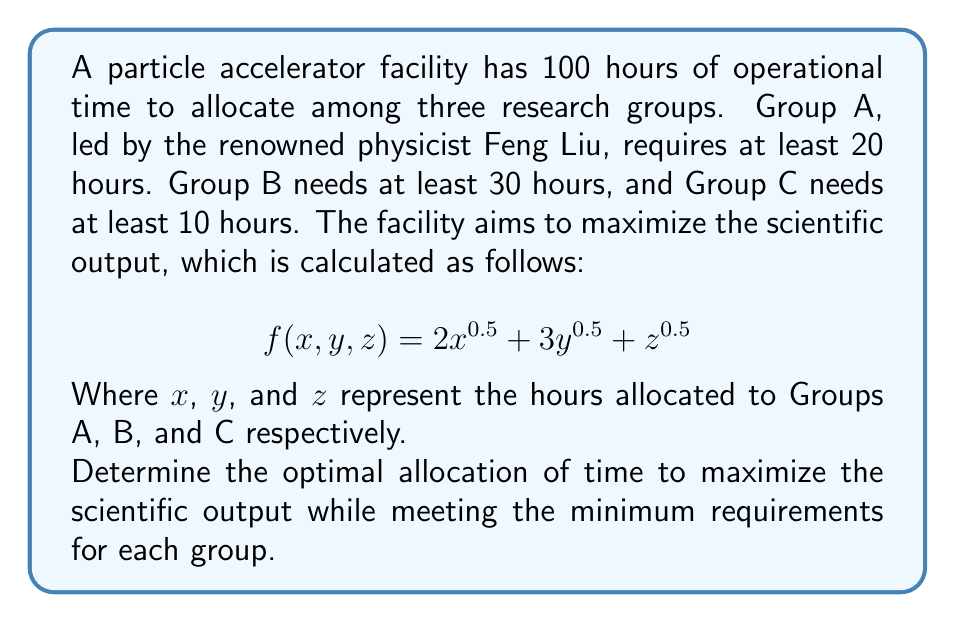Provide a solution to this math problem. To solve this problem, we'll use the method of Lagrange multipliers, which is commonly used in optimization problems with constraints.

1) First, let's define our constraints:
   $x + y + z = 100$ (total time constraint)
   $x \geq 20$, $y \geq 30$, $z \geq 10$ (minimum time requirements)

2) We need to maximize the function:
   $f(x, y, z) = 2x^{0.5} + 3y^{0.5} + z^{0.5}$

3) Let's form the Lagrangian:
   $L(x, y, z, \lambda) = 2x^{0.5} + 3y^{0.5} + z^{0.5} - \lambda(x + y + z - 100)$

4) Now, we take partial derivatives and set them to zero:
   $\frac{\partial L}{\partial x} = x^{-0.5} - \lambda = 0$
   $\frac{\partial L}{\partial y} = \frac{3}{2}y^{-0.5} - \lambda = 0$
   $\frac{\partial L}{\partial z} = \frac{1}{2}z^{-0.5} - \lambda = 0$
   $\frac{\partial L}{\partial \lambda} = x + y + z - 100 = 0$

5) From these equations, we can derive:
   $x = \frac{1}{\lambda^2}$
   $y = \frac{9}{4\lambda^2}$
   $z = \frac{1}{4\lambda^2}$

6) Substituting these into the total time constraint:
   $\frac{1}{\lambda^2} + \frac{9}{4\lambda^2} + \frac{1}{4\lambda^2} = 100$
   $\frac{16}{4\lambda^2} = 100$
   $\lambda^2 = \frac{1}{25}$
   $\lambda = \frac{1}{5}$

7) Now we can calculate the optimal values:
   $x = 25$
   $y = 56.25$
   $z = 18.75$

8) However, we need to check if these values satisfy our minimum time requirements. While $x$ and $y$ do, $z$ does not meet its minimum of 10 hours.

9) Therefore, we need to adjust our solution. We'll set $z = 10$ and redistribute the remaining time between $x$ and $y$ using the same ratio as before:
   
   Remaining time: $100 - 10 = 90$ hours
   Ratio of $x$ to $y$: $25 : 56.25 = 4 : 9$

   $x = 90 * \frac{4}{13} = 27.69$ hours
   $y = 90 * \frac{9}{13} = 62.31$ hours

10) This new allocation satisfies all constraints and maximizes the output given the constraints.
Answer: The optimal allocation of time is:
Group A (Feng Liu's group): 27.69 hours
Group B: 62.31 hours
Group C: 10 hours 